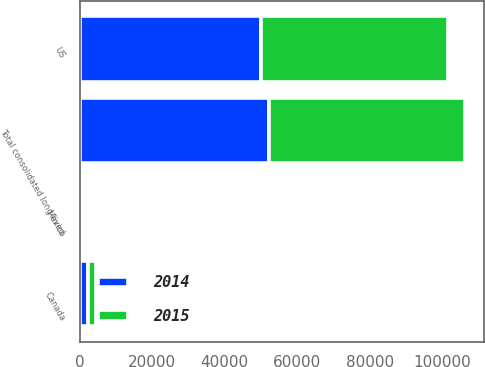Convert chart to OTSL. <chart><loc_0><loc_0><loc_500><loc_500><stacked_bar_chart><ecel><fcel>US<fcel>Canada<fcel>Mexico<fcel>Total consolidated long-lived<nl><fcel>2015<fcel>51679<fcel>2193<fcel>67<fcel>53939<nl><fcel>2014<fcel>49992<fcel>2268<fcel>81<fcel>52341<nl></chart> 